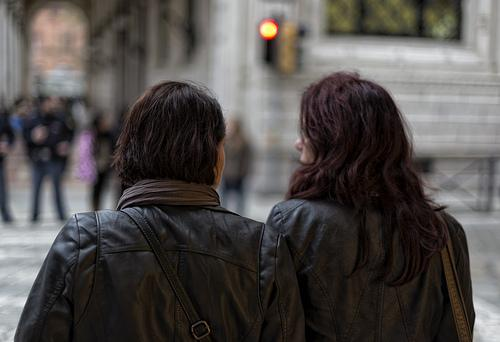In an artistic manner, describe the hairstyles and accessories of the two main subjects. One woman gracefully adorns short hair with ravishing red highlights, while the other's luscious long hair cascades over her upper back. Their stylish ensembles are completed with matching black leather jackets and elegant scarves. Provide a complete scene description using as much detail as possible. In a bustling urban setting, two women donning matching black leather jackets stand side-by-side, seemingly waiting to cross the street at a red traffic signal. With striking hairstyles and scarves, they gracefully balance their purses, one with the strap across the back and another on the shoulder. The out-of-focus background captures various elements, including a grey stone building, people on the sidewalk, a rounded archway, and a black metal fence. Mention the main colors and their presence in the image. Prominent colors include black in leather jackets, brown in the scarf around the neck, red in the traffic signal and highlights in the hair, and grey in the stone building. Identify any elements in the architecture of the environment. Distinct architectural elements include a grey stone building with a rounded archway and a black metal fence. How many people are in the image and what are they doing? There are several people in the image, with two women standing next to each other waiting to cross the street, while others are standing or walking on the sidewalk and across the street. What are the traffic signal colors visible in the image? The traffic signal colors visible are red and yellow. Describe the two women's purses and their straps. One woman has a purse with a strap running across her back and hanging from her shoulder, while the other wears her purse on the shoulder with a black strap. What is the state of focus in the background of the image? The background of the image is out of focus. Describe the primary activity and main objects present in this image. Two women wearing black leather jackets are standing next to each other, waiting to cross the street at a red traffic signal. Narrate the mood or feeling conveyed by the image. The image conveys a casual, urban atmosphere where the two women stylishly await their moment to cross the street, engaging in a moment of camaraderie amidst the bustling city backdrop. Which way is the head of one woman facing? Slightly turned to the side. Select the correct description of the scene:  b) Two women wearing leather jackets are waiting to cross the street. Describe the building's exterior and a notable architectural feature in the background. The grey stone building has a rounded archway. Is the person in the front wearing a blue jacket? The instructions mention "two women wearing black jackets" and "women are wearing black jackets", so the person in the front is actually wearing a black jacket, not a blue one. Identify the event taking place in the scene. Two women waiting to cross the street. Describe the location of the purse strap on one woman. Across her back and over her shoulder What is the color of the traffic signal light? Red Is there a man with a hat in the scene? No, it's not mentioned in the image. Is there a scarf around the neck of one of the women? Yes, a brown scarf. Write a poetic description of the scene. Upon the streets of afternoon, two women stand in waiting, Can you find a purple scarf around the neck of one of the women? The given attributes mention a "brown scarf around the neck" and "brown scarf around neck". Introducing a purple scarf as a direction creates confusion and deviates from the actual object color. Are the people across the street standing or walking? Standing Is there a fence in the image? If so, what material is it made of? Yes, there is a black metal fence. Create a story involving the two women based on the contents of the image. The two women, close friends, walked down the street wearing matching black leather jackets. They paused, waiting for the red traffic signal to change before crossing the street, discussing their day ahead. Is there an umbrella lying on the ground near the women? None of the given image attributes mention an umbrella on the ground or anywhere else in the scene. This instruction introduces a completely unrelated object, making it misleading. How is the purse strap hanging on the woman with long hair? On her shoulder What is out of focus in the image? The background Can you see the green traffic light in the image? The given attributes mention a "red traffic signal" and a "yellow traffic light," but there is no mention of a green traffic light. So, this instruction introduces a wrong color for the traffic light. Determine the two women's hair styles. One woman has short hair and the other has long hair. How many people are walking down the street together? Two What kind of jackets are the two women wearing? Black leather jackets Describe the bag's strap on the woman with short hair. A black strap running across her back and clasp on her shoulder. Explain the architectural feature that can be seen in the background. A rounded archway on a grey stone building. What are the women waiting to do? Cross the street Are the women standing next to a white metal fence? According to the image attributes, there is a "black metal fence" present in the scene. Introducing a white metal fence in the instruction deviates from the actual object color, making it misleading. 